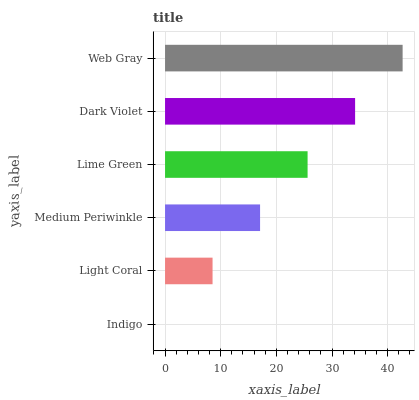Is Indigo the minimum?
Answer yes or no. Yes. Is Web Gray the maximum?
Answer yes or no. Yes. Is Light Coral the minimum?
Answer yes or no. No. Is Light Coral the maximum?
Answer yes or no. No. Is Light Coral greater than Indigo?
Answer yes or no. Yes. Is Indigo less than Light Coral?
Answer yes or no. Yes. Is Indigo greater than Light Coral?
Answer yes or no. No. Is Light Coral less than Indigo?
Answer yes or no. No. Is Lime Green the high median?
Answer yes or no. Yes. Is Medium Periwinkle the low median?
Answer yes or no. Yes. Is Dark Violet the high median?
Answer yes or no. No. Is Light Coral the low median?
Answer yes or no. No. 